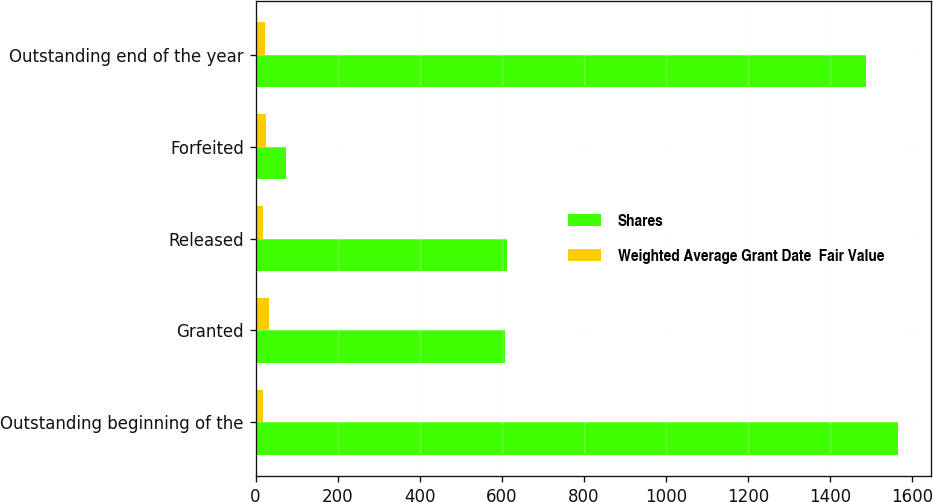Convert chart. <chart><loc_0><loc_0><loc_500><loc_500><stacked_bar_chart><ecel><fcel>Outstanding beginning of the<fcel>Granted<fcel>Released<fcel>Forfeited<fcel>Outstanding end of the year<nl><fcel>Shares<fcel>1567<fcel>609<fcel>614<fcel>75<fcel>1487<nl><fcel>Weighted Average Grant Date  Fair Value<fcel>18.23<fcel>33.16<fcel>17.61<fcel>26.03<fcel>24.05<nl></chart> 